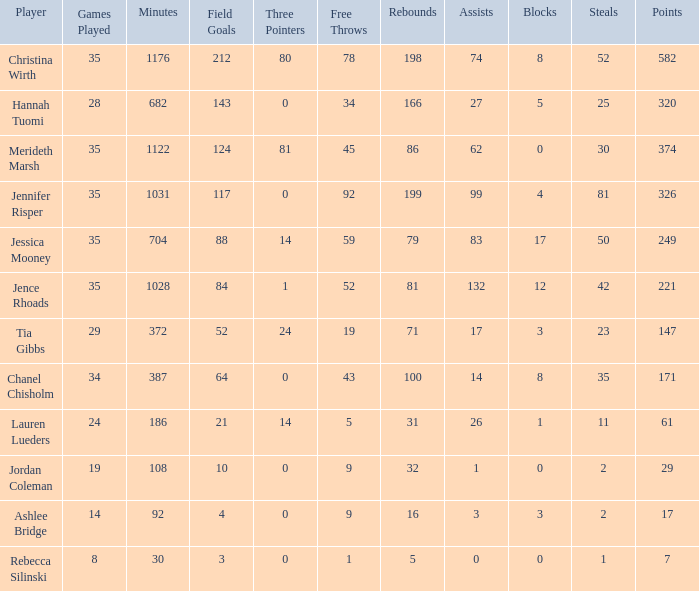What is the lowest number of 3 pointers that occured in games with 52 steals? 80.0. 